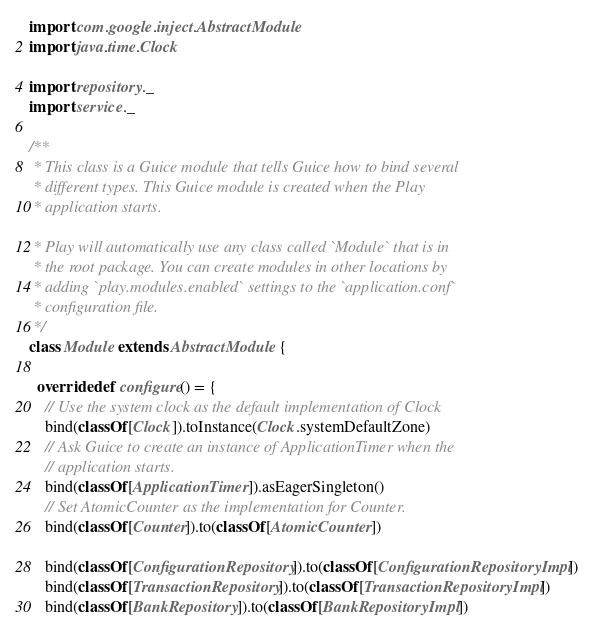<code> <loc_0><loc_0><loc_500><loc_500><_Scala_>import com.google.inject.AbstractModule
import java.time.Clock

import repository._
import service._

/**
 * This class is a Guice module that tells Guice how to bind several
 * different types. This Guice module is created when the Play
 * application starts.

 * Play will automatically use any class called `Module` that is in
 * the root package. You can create modules in other locations by
 * adding `play.modules.enabled` settings to the `application.conf`
 * configuration file.
 */
class Module extends AbstractModule {

  override def configure() = {
    // Use the system clock as the default implementation of Clock
    bind(classOf[Clock]).toInstance(Clock.systemDefaultZone)
    // Ask Guice to create an instance of ApplicationTimer when the
    // application starts.
    bind(classOf[ApplicationTimer]).asEagerSingleton()
    // Set AtomicCounter as the implementation for Counter.
    bind(classOf[Counter]).to(classOf[AtomicCounter])

    bind(classOf[ConfigurationRepository]).to(classOf[ConfigurationRepositoryImpl])
    bind(classOf[TransactionRepository]).to(classOf[TransactionRepositoryImpl])
    bind(classOf[BankRepository]).to(classOf[BankRepositoryImpl])</code> 